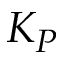Convert formula to latex. <formula><loc_0><loc_0><loc_500><loc_500>K _ { P }</formula> 